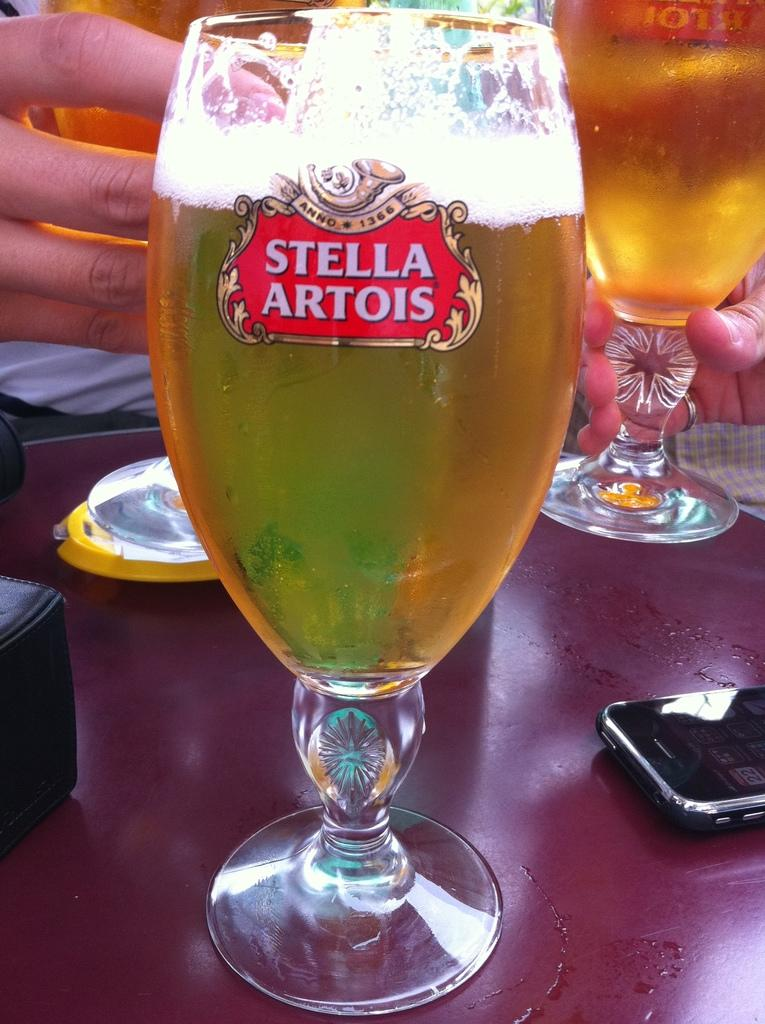<image>
Provide a brief description of the given image. a glass with the words stella artois on it 